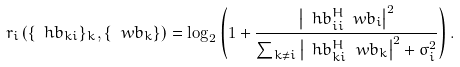Convert formula to latex. <formula><loc_0><loc_0><loc_500><loc_500>r _ { i } \left ( \{ \ h b _ { k i } \} _ { k } , \{ \ w b _ { k } \} \right ) = \log _ { 2 } \left ( 1 + \frac { \left | \ h b _ { i i } ^ { H } \ w b _ { i } \right | ^ { 2 } } { \sum _ { k \neq { i } } \left | \ h b _ { k i } ^ { H } \ w b _ { k } \right | ^ { 2 } + \sigma ^ { 2 } _ { i } } \right ) .</formula> 